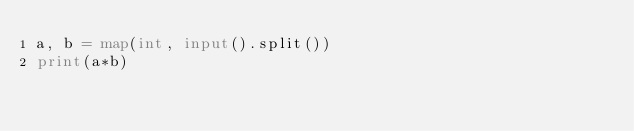<code> <loc_0><loc_0><loc_500><loc_500><_Python_>a, b = map(int, input().split())
print(a*b)</code> 